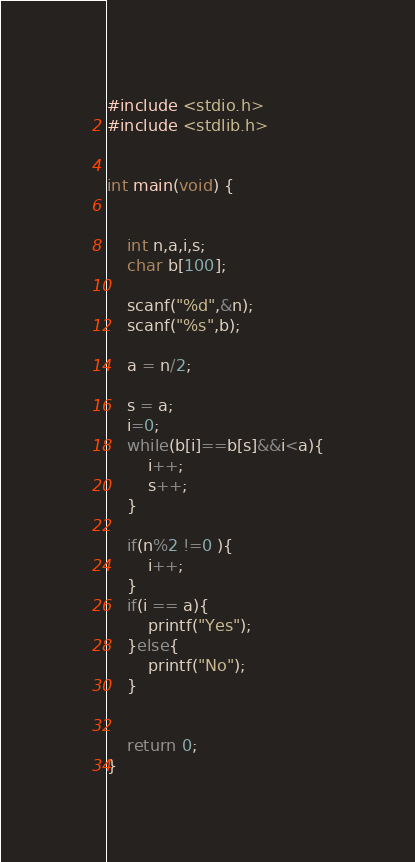<code> <loc_0><loc_0><loc_500><loc_500><_C_>#include <stdio.h>
#include <stdlib.h>
 
 
int main(void) {
 
 
	int n,a,i,s;
	char b[100];
 
	scanf("%d",&n);
	scanf("%s",b);
 
	a = n/2;
 
	s = a;
	i=0;
	while(b[i]==b[s]&&i<a){
		i++;
		s++;
	}
 
	if(n%2 !=0 ){
		i++;
	}
	if(i == a){
		printf("Yes");
	}else{
		printf("No");
	}
 
 
	return 0;
}</code> 